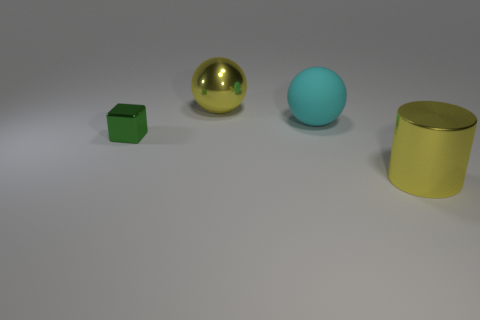Does the yellow shiny object in front of the green metallic thing have the same size as the yellow metal thing on the left side of the cyan matte thing?
Make the answer very short. Yes. What shape is the large yellow thing to the left of the rubber thing that is on the right side of the yellow metal object on the left side of the cyan sphere?
Your answer should be very brief. Sphere. Is there anything else that is the same material as the tiny thing?
Offer a very short reply. Yes. The other yellow thing that is the same shape as the big rubber thing is what size?
Keep it short and to the point. Large. There is a object that is both behind the green block and on the right side of the big yellow metal ball; what is its color?
Offer a very short reply. Cyan. Is the material of the large yellow ball the same as the large yellow object that is in front of the cyan sphere?
Provide a short and direct response. Yes. Is the number of large cyan matte things that are behind the large cyan sphere less than the number of big shiny cylinders?
Your response must be concise. Yes. What number of other objects are there of the same shape as the matte object?
Your answer should be compact. 1. Are there any other things that are the same color as the small object?
Offer a very short reply. No. Is the color of the rubber sphere the same as the large metallic object that is left of the yellow cylinder?
Offer a terse response. No. 